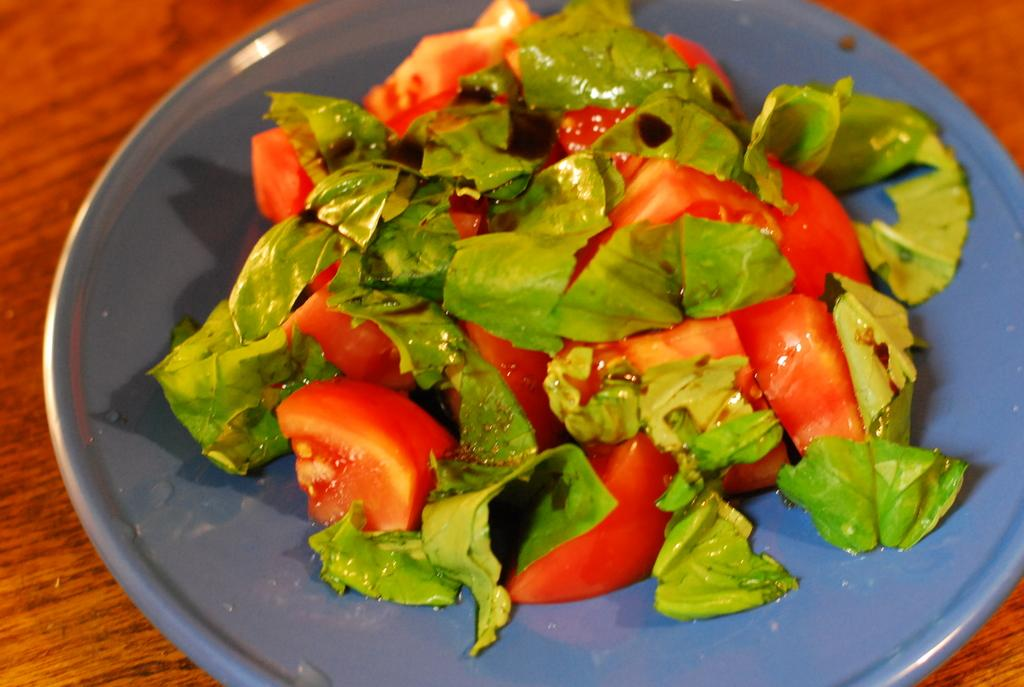What is present on the plate in the image? There is food on the plate in the image. Can you describe the wooden object in the background of the image? There is a wooden object that looks like a table in the background of the image. Where is the cave located in the image? There is no cave present in the image. What is the best route to reach the nest in the image? There is no nest present in the image. 